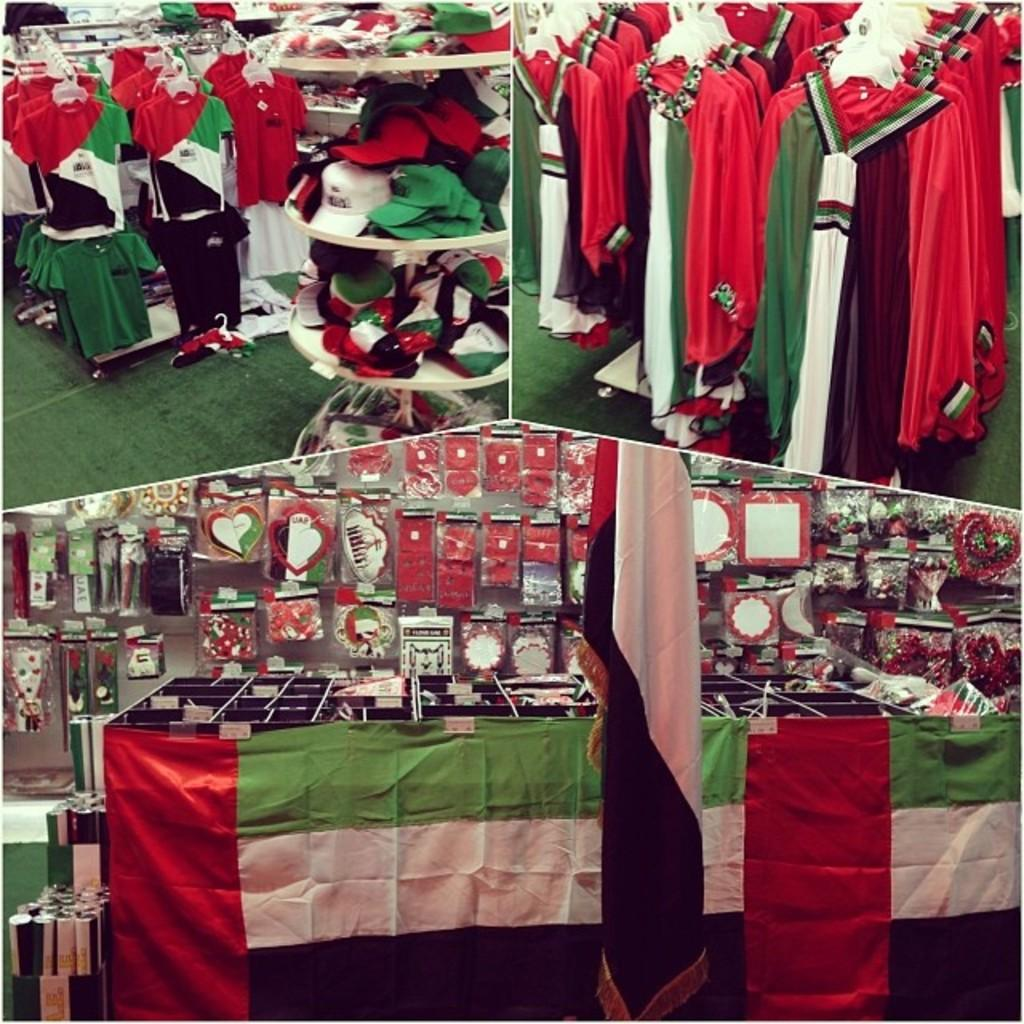What type of artwork is depicted in the image? The image is a collage of different pictures. What items related to clothing can be seen in the collage? There are clothes on a hanger and caps in the collage. What other objects are present in the collage? There are flags in the collage. How many brothers are depicted in the collage? There are no brothers depicted in the collage; it features a collection of unrelated pictures. What type of engine can be seen in the image? There is no engine present in the image; it is a collage of different pictures, including clothes, caps, and flags. 